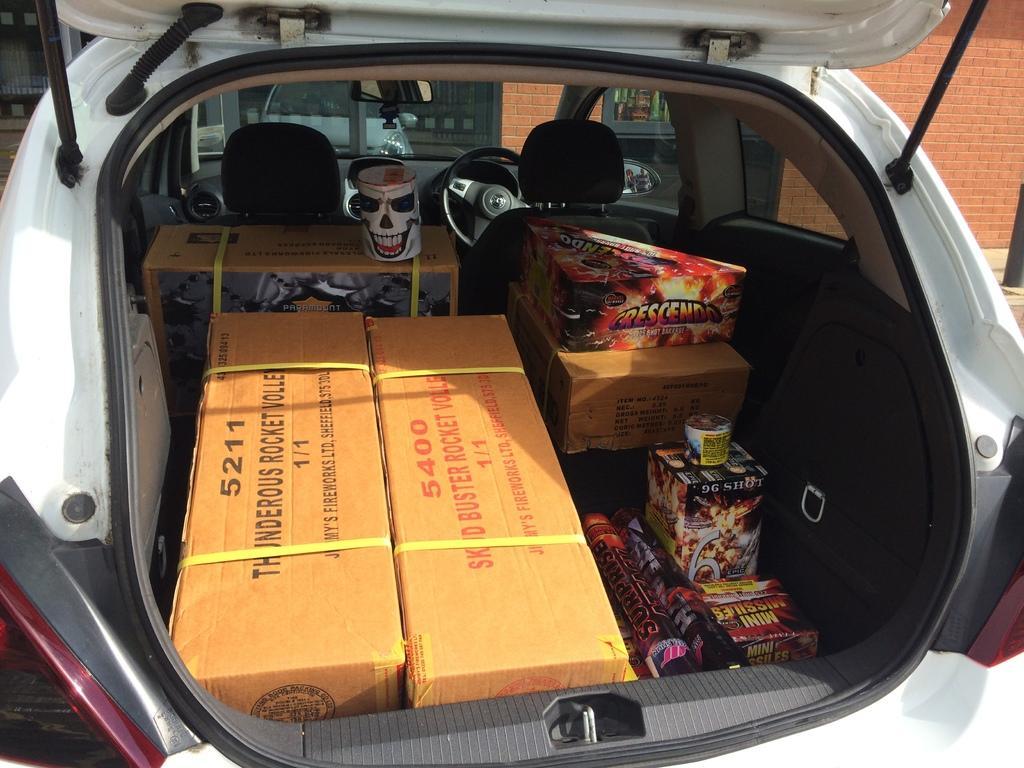Please provide a concise description of this image. In this image we can see a white color vehicle with some objects in it and in the background we can see a wall. 